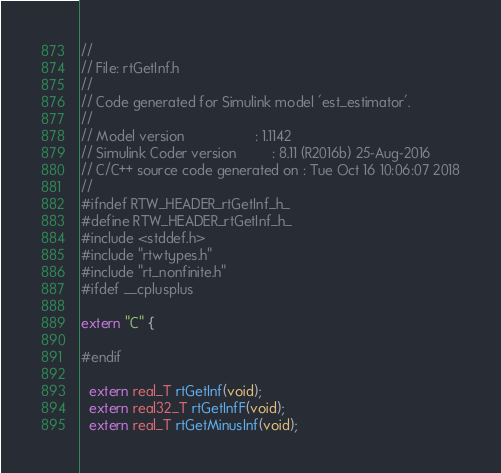Convert code to text. <code><loc_0><loc_0><loc_500><loc_500><_C_>//
// File: rtGetInf.h
//
// Code generated for Simulink model 'est_estimator'.
//
// Model version                  : 1.1142
// Simulink Coder version         : 8.11 (R2016b) 25-Aug-2016
// C/C++ source code generated on : Tue Oct 16 10:06:07 2018
//
#ifndef RTW_HEADER_rtGetInf_h_
#define RTW_HEADER_rtGetInf_h_
#include <stddef.h>
#include "rtwtypes.h"
#include "rt_nonfinite.h"
#ifdef __cplusplus

extern "C" {

#endif

  extern real_T rtGetInf(void);
  extern real32_T rtGetInfF(void);
  extern real_T rtGetMinusInf(void);</code> 